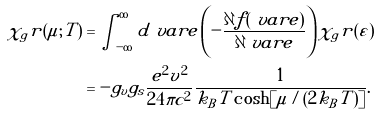<formula> <loc_0><loc_0><loc_500><loc_500>\chi _ { g } r ( \mu ; T ) & = \int _ { - \infty } ^ { \infty } d \ v a r e \left ( - \frac { \partial f ( \ v a r e ) } { \partial \ v a r e } \right ) \chi _ { g } r ( \varepsilon ) \\ & = - g _ { v } g _ { s } \frac { e ^ { 2 } v ^ { 2 } } { 2 4 \pi c ^ { 2 } } \frac { 1 } { k _ { B } T \cosh [ \mu / ( 2 k _ { B } T ) ] } .</formula> 